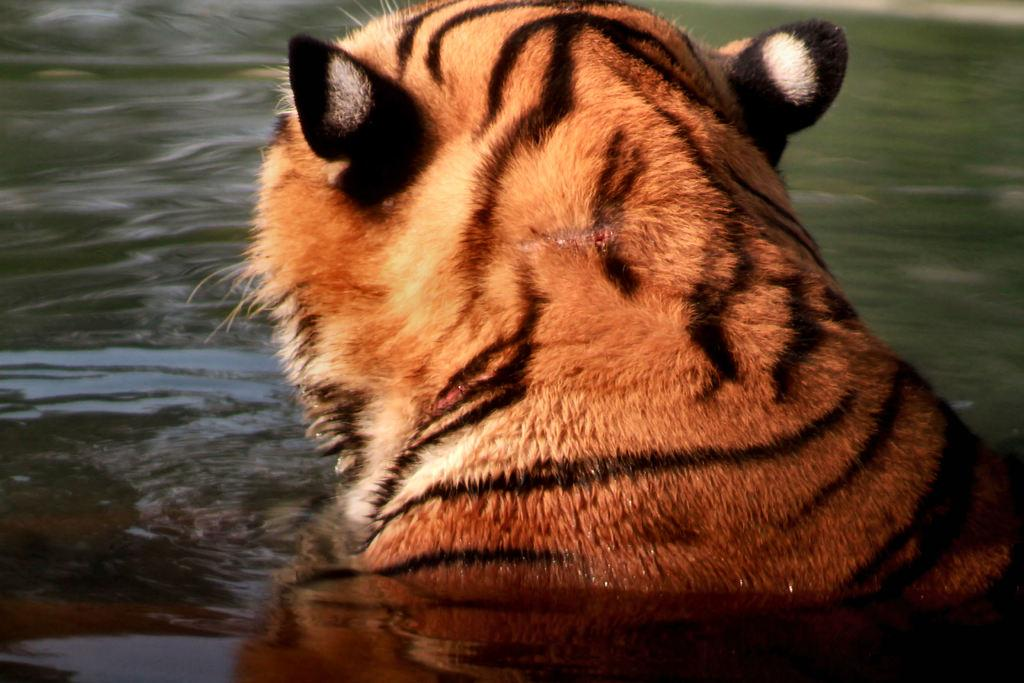What animal is in the image? There is a tiger in the image. Where is the tiger located in the image? The tiger is in the water. How many chickens are swimming with the tiger in the image? There are no chickens present in the image; it only features a tiger in the water. 